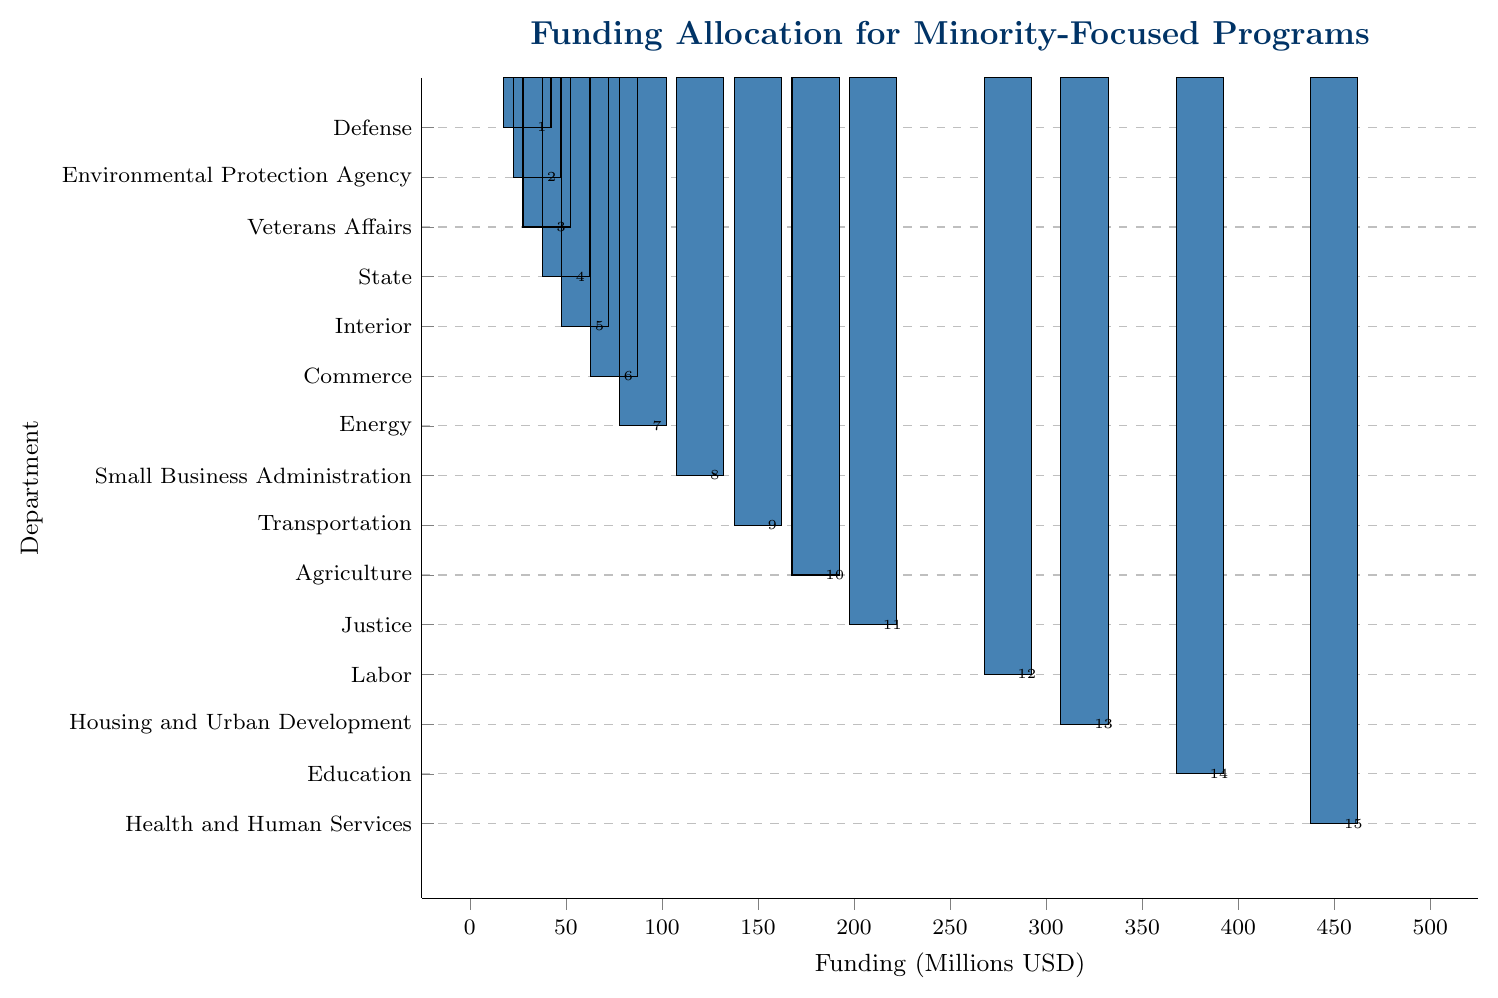Which department receives the highest funding? By looking at the bar chart, the department with the tallest bar receives the highest funding. The tallest bar corresponds to Health and Human Services, which receives 450 million USD.
Answer: Health and Human Services Which department receives the lowest funding? The department with the shortest bar in the bar chart receives the lowest funding. The shortest bar corresponds to Defense, which receives 30 million USD.
Answer: Defense How much more funding does Health and Human Services receive compared to Defense? From the chart, Health and Human Services receives 450 million USD and Defense receives 30 million USD. The difference in funding is calculated as 450 - 30 = 420 million USD.
Answer: 420 million USD What is the total funding allocated to Justice, Labor, and Housing and Urban Development? According to the chart, the funding for Justice, Labor, and Housing and Urban Development is 210 million USD, 280 million USD, and 320 million USD respectively. Adding these gives 210 + 280 + 320 = 810 million USD.
Answer: 810 million USD Which department receives more funding, Education or Agriculture, and by how much? From the chart, Education receives 380 million USD and Agriculture receives 180 million USD. The difference is 380 - 180 = 200 million USD, showing Education receives more funding by 200 million USD.
Answer: Education by 200 million USD What is the average funding for the Small Business Administration, Transportation, and Energy departments? The funding for the Small Business Administration, Transportation, and Energy is 120 million USD, 150 million USD, and 90 million USD respectively. The sum is 120 + 150 + 90 = 360 million USD. The average is calculated as 360 / 3 = 120 million USD.
Answer: 120 million USD Compare the funding of the Interior and State departments. Which one gets more funding and what is the difference? The Interior department has 60 million USD while the State department has 50 million USD. The Interior department receives more funding by 60 - 50 = 10 million USD.
Answer: Interior by 10 million USD Summarize the funding differences between the departments receiving more than 300 million USD and those receiving less than 100 million USD. Departments receiving more than 300 million USD are Health and Human Services (450 million), Education (380 million), and Housing and Urban Development (320 million). Those receiving less than 100 million USD are Energy (90 million), Commerce (75 million), Interior (60 million), State (50 million), Veterans Affairs (40 million), Environmental Protection Agency (35 million), and Defense (30 million). The total for those over 300 million USD is 450 + 380 + 320 = 1,150 million USD, while the total for those under 100 million USD is 90 + 75 + 60 + 50 + 40 + 35 + 30 = 380 million USD. The difference is 1,150 - 380 = 770 million USD.
Answer: 770 million USD Which department(s) have funding close to 200 million USD, and how close are they? From the chart, Justice has 210 million USD, and Agriculture has 180 million USD. Justice is 10 million USD above 200 million (210 - 200 = 10), and Agriculture is 20 million USD below 200 million (200 - 180 = 20).
Answer: Justice (210), Agriculture (180) 